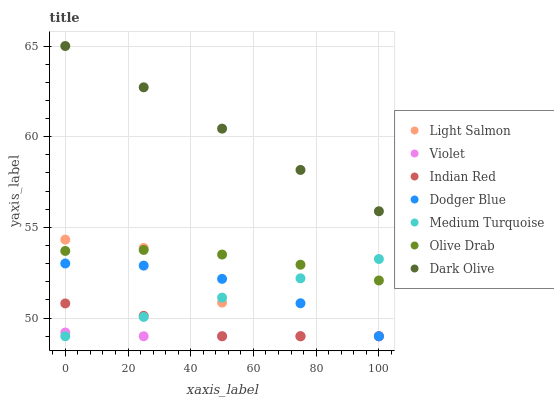Does Violet have the minimum area under the curve?
Answer yes or no. Yes. Does Dark Olive have the maximum area under the curve?
Answer yes or no. Yes. Does Indian Red have the minimum area under the curve?
Answer yes or no. No. Does Indian Red have the maximum area under the curve?
Answer yes or no. No. Is Medium Turquoise the smoothest?
Answer yes or no. Yes. Is Light Salmon the roughest?
Answer yes or no. Yes. Is Indian Red the smoothest?
Answer yes or no. No. Is Indian Red the roughest?
Answer yes or no. No. Does Light Salmon have the lowest value?
Answer yes or no. Yes. Does Dark Olive have the lowest value?
Answer yes or no. No. Does Dark Olive have the highest value?
Answer yes or no. Yes. Does Indian Red have the highest value?
Answer yes or no. No. Is Olive Drab less than Dark Olive?
Answer yes or no. Yes. Is Olive Drab greater than Dodger Blue?
Answer yes or no. Yes. Does Dodger Blue intersect Medium Turquoise?
Answer yes or no. Yes. Is Dodger Blue less than Medium Turquoise?
Answer yes or no. No. Is Dodger Blue greater than Medium Turquoise?
Answer yes or no. No. Does Olive Drab intersect Dark Olive?
Answer yes or no. No. 